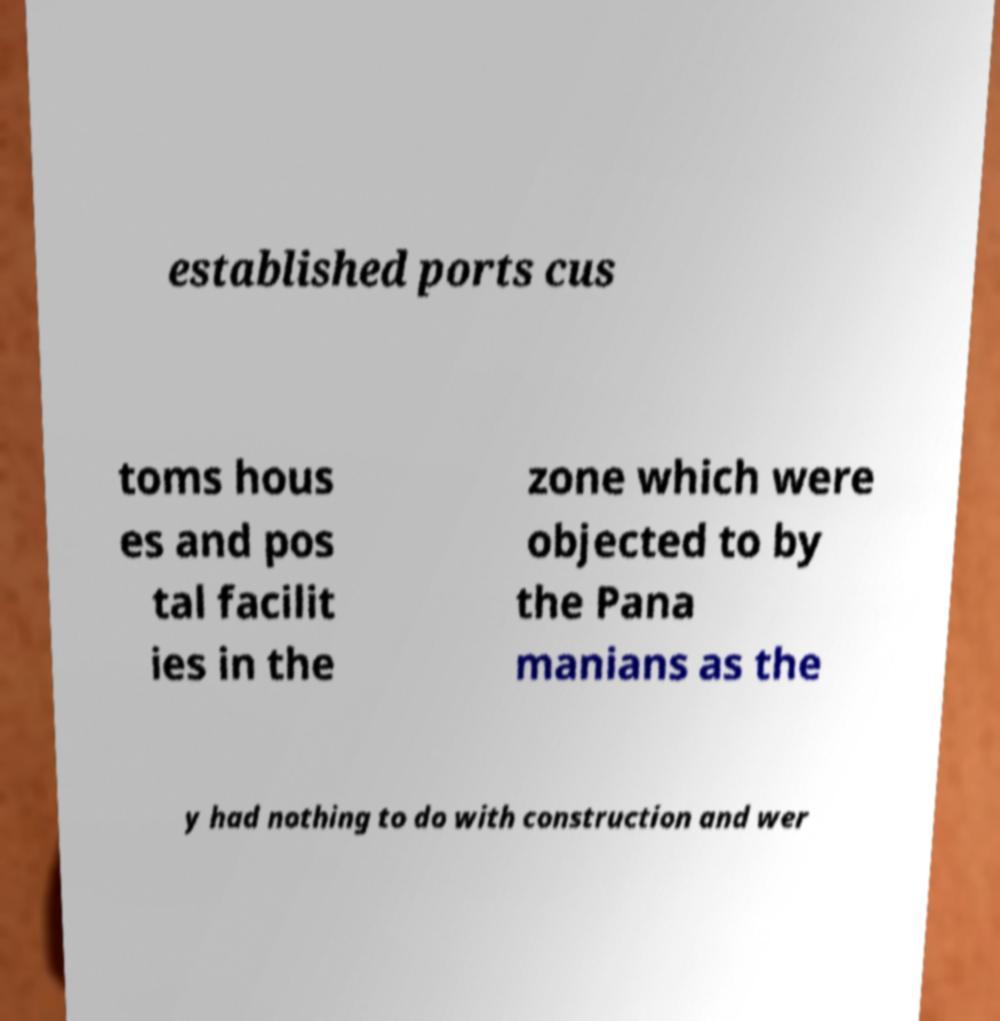There's text embedded in this image that I need extracted. Can you transcribe it verbatim? established ports cus toms hous es and pos tal facilit ies in the zone which were objected to by the Pana manians as the y had nothing to do with construction and wer 